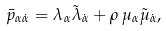Convert formula to latex. <formula><loc_0><loc_0><loc_500><loc_500>\bar { p } _ { \alpha \dot { \alpha } } = \lambda _ { \alpha } \tilde { \lambda } _ { \dot { \alpha } } + \rho \, \mu _ { \alpha } \tilde { \mu } _ { \dot { \alpha } } ,</formula> 